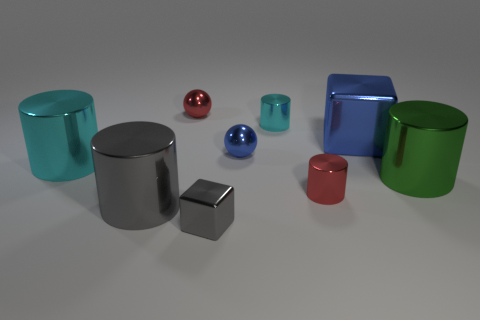Add 1 yellow metal spheres. How many objects exist? 10 Subtract all large green metal cylinders. How many cylinders are left? 4 Subtract all red spheres. How many red blocks are left? 0 Subtract all tiny cyan things. Subtract all big brown rubber things. How many objects are left? 8 Add 6 big cylinders. How many big cylinders are left? 9 Add 5 tiny cyan metal cylinders. How many tiny cyan metal cylinders exist? 6 Subtract all gray cylinders. How many cylinders are left? 4 Subtract 0 purple cubes. How many objects are left? 9 Subtract all cubes. How many objects are left? 7 Subtract 1 cubes. How many cubes are left? 1 